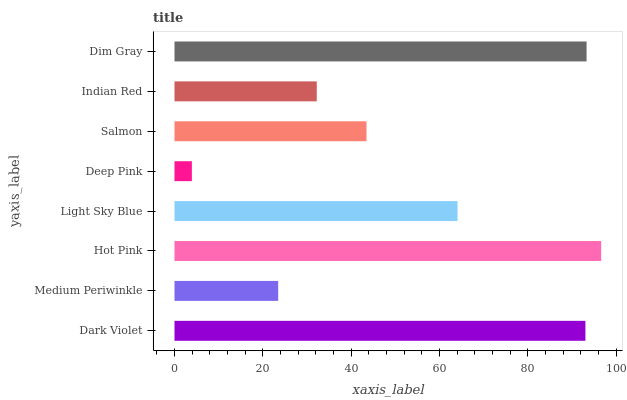Is Deep Pink the minimum?
Answer yes or no. Yes. Is Hot Pink the maximum?
Answer yes or no. Yes. Is Medium Periwinkle the minimum?
Answer yes or no. No. Is Medium Periwinkle the maximum?
Answer yes or no. No. Is Dark Violet greater than Medium Periwinkle?
Answer yes or no. Yes. Is Medium Periwinkle less than Dark Violet?
Answer yes or no. Yes. Is Medium Periwinkle greater than Dark Violet?
Answer yes or no. No. Is Dark Violet less than Medium Periwinkle?
Answer yes or no. No. Is Light Sky Blue the high median?
Answer yes or no. Yes. Is Salmon the low median?
Answer yes or no. Yes. Is Medium Periwinkle the high median?
Answer yes or no. No. Is Dark Violet the low median?
Answer yes or no. No. 